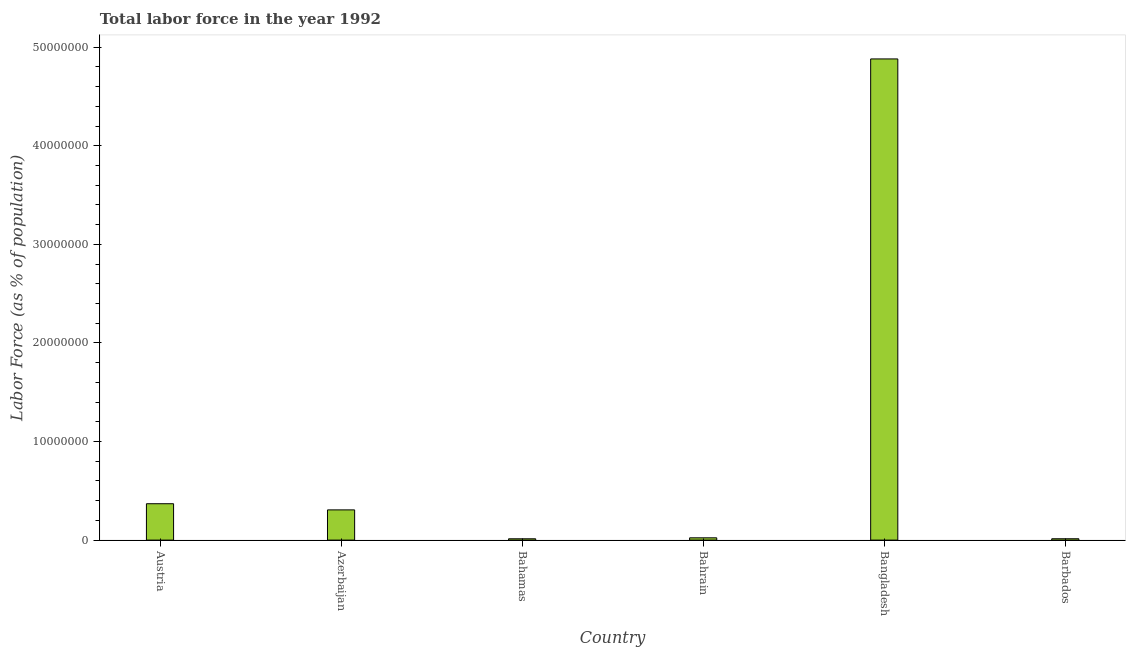Does the graph contain grids?
Provide a succinct answer. No. What is the title of the graph?
Offer a terse response. Total labor force in the year 1992. What is the label or title of the X-axis?
Your response must be concise. Country. What is the label or title of the Y-axis?
Provide a short and direct response. Labor Force (as % of population). What is the total labor force in Bahamas?
Offer a very short reply. 1.34e+05. Across all countries, what is the maximum total labor force?
Your answer should be very brief. 4.88e+07. Across all countries, what is the minimum total labor force?
Your answer should be compact. 1.34e+05. In which country was the total labor force minimum?
Your answer should be compact. Bahamas. What is the sum of the total labor force?
Offer a very short reply. 5.61e+07. What is the difference between the total labor force in Azerbaijan and Bahamas?
Keep it short and to the point. 2.93e+06. What is the average total labor force per country?
Offer a very short reply. 9.34e+06. What is the median total labor force?
Your response must be concise. 1.65e+06. What is the ratio of the total labor force in Azerbaijan to that in Barbados?
Your answer should be compact. 22.37. Is the total labor force in Bangladesh less than that in Barbados?
Make the answer very short. No. Is the difference between the total labor force in Austria and Bangladesh greater than the difference between any two countries?
Offer a terse response. No. What is the difference between the highest and the second highest total labor force?
Provide a succinct answer. 4.51e+07. What is the difference between the highest and the lowest total labor force?
Your answer should be very brief. 4.87e+07. In how many countries, is the total labor force greater than the average total labor force taken over all countries?
Ensure brevity in your answer.  1. How many countries are there in the graph?
Your answer should be very brief. 6. What is the difference between two consecutive major ticks on the Y-axis?
Ensure brevity in your answer.  1.00e+07. What is the Labor Force (as % of population) of Austria?
Give a very brief answer. 3.69e+06. What is the Labor Force (as % of population) of Azerbaijan?
Your answer should be very brief. 3.07e+06. What is the Labor Force (as % of population) in Bahamas?
Your answer should be very brief. 1.34e+05. What is the Labor Force (as % of population) in Bahrain?
Give a very brief answer. 2.31e+05. What is the Labor Force (as % of population) of Bangladesh?
Your response must be concise. 4.88e+07. What is the Labor Force (as % of population) of Barbados?
Your response must be concise. 1.37e+05. What is the difference between the Labor Force (as % of population) in Austria and Azerbaijan?
Your response must be concise. 6.25e+05. What is the difference between the Labor Force (as % of population) in Austria and Bahamas?
Your answer should be very brief. 3.56e+06. What is the difference between the Labor Force (as % of population) in Austria and Bahrain?
Make the answer very short. 3.46e+06. What is the difference between the Labor Force (as % of population) in Austria and Bangladesh?
Provide a succinct answer. -4.51e+07. What is the difference between the Labor Force (as % of population) in Austria and Barbados?
Provide a short and direct response. 3.55e+06. What is the difference between the Labor Force (as % of population) in Azerbaijan and Bahamas?
Give a very brief answer. 2.93e+06. What is the difference between the Labor Force (as % of population) in Azerbaijan and Bahrain?
Ensure brevity in your answer.  2.83e+06. What is the difference between the Labor Force (as % of population) in Azerbaijan and Bangladesh?
Offer a very short reply. -4.57e+07. What is the difference between the Labor Force (as % of population) in Azerbaijan and Barbados?
Provide a succinct answer. 2.93e+06. What is the difference between the Labor Force (as % of population) in Bahamas and Bahrain?
Offer a very short reply. -9.73e+04. What is the difference between the Labor Force (as % of population) in Bahamas and Bangladesh?
Offer a terse response. -4.87e+07. What is the difference between the Labor Force (as % of population) in Bahamas and Barbados?
Your answer should be compact. -3279. What is the difference between the Labor Force (as % of population) in Bahrain and Bangladesh?
Your answer should be compact. -4.86e+07. What is the difference between the Labor Force (as % of population) in Bahrain and Barbados?
Offer a terse response. 9.40e+04. What is the difference between the Labor Force (as % of population) in Bangladesh and Barbados?
Ensure brevity in your answer.  4.87e+07. What is the ratio of the Labor Force (as % of population) in Austria to that in Azerbaijan?
Offer a very short reply. 1.2. What is the ratio of the Labor Force (as % of population) in Austria to that in Bahamas?
Your answer should be compact. 27.59. What is the ratio of the Labor Force (as % of population) in Austria to that in Bahrain?
Your response must be concise. 15.97. What is the ratio of the Labor Force (as % of population) in Austria to that in Bangladesh?
Provide a short and direct response. 0.08. What is the ratio of the Labor Force (as % of population) in Austria to that in Barbados?
Give a very brief answer. 26.93. What is the ratio of the Labor Force (as % of population) in Azerbaijan to that in Bahamas?
Your response must be concise. 22.92. What is the ratio of the Labor Force (as % of population) in Azerbaijan to that in Bahrain?
Give a very brief answer. 13.27. What is the ratio of the Labor Force (as % of population) in Azerbaijan to that in Bangladesh?
Provide a short and direct response. 0.06. What is the ratio of the Labor Force (as % of population) in Azerbaijan to that in Barbados?
Keep it short and to the point. 22.37. What is the ratio of the Labor Force (as % of population) in Bahamas to that in Bahrain?
Offer a terse response. 0.58. What is the ratio of the Labor Force (as % of population) in Bahamas to that in Bangladesh?
Offer a very short reply. 0. What is the ratio of the Labor Force (as % of population) in Bahamas to that in Barbados?
Offer a terse response. 0.98. What is the ratio of the Labor Force (as % of population) in Bahrain to that in Bangladesh?
Your response must be concise. 0.01. What is the ratio of the Labor Force (as % of population) in Bahrain to that in Barbados?
Keep it short and to the point. 1.69. What is the ratio of the Labor Force (as % of population) in Bangladesh to that in Barbados?
Provide a short and direct response. 356.22. 